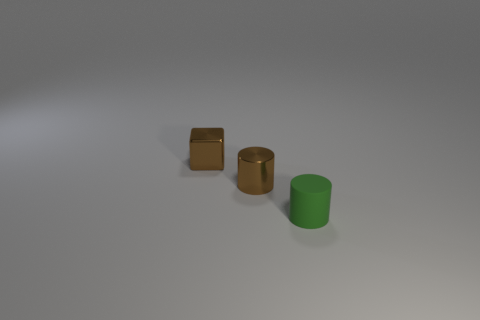Add 2 brown objects. How many objects exist? 5 Subtract 2 cylinders. How many cylinders are left? 0 Subtract all brown cylinders. How many cylinders are left? 1 Subtract all yellow cylinders. Subtract all gray cubes. How many cylinders are left? 2 Subtract all cyan blocks. Subtract all tiny objects. How many objects are left? 0 Add 1 tiny brown metallic cylinders. How many tiny brown metallic cylinders are left? 2 Add 1 large purple metal spheres. How many large purple metal spheres exist? 1 Subtract 0 blue cylinders. How many objects are left? 3 Subtract all blocks. How many objects are left? 2 